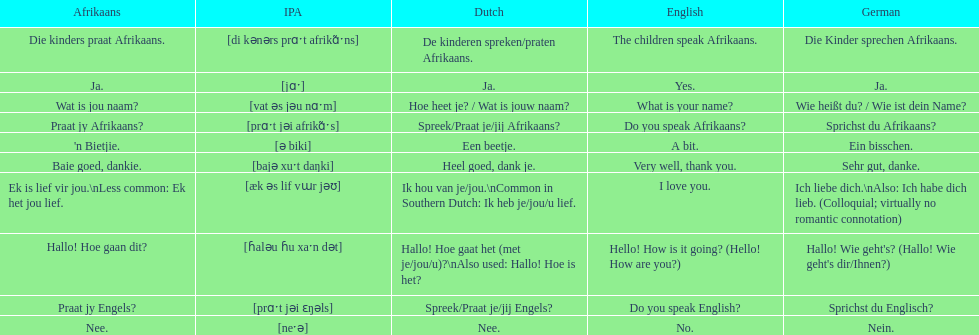Translate the following into german: die kinders praat afrikaans. Die Kinder sprechen Afrikaans. 